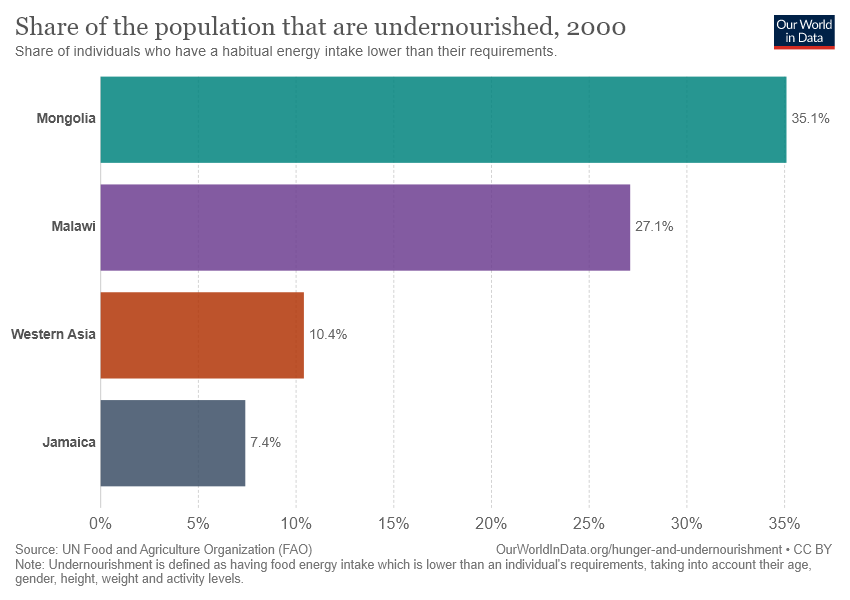Specify some key components in this picture. According to the bar graph, Mongolia has the highest level of undernourishment among all the countries shown. The average value of Western Asia and Jamaica is 8.9. 